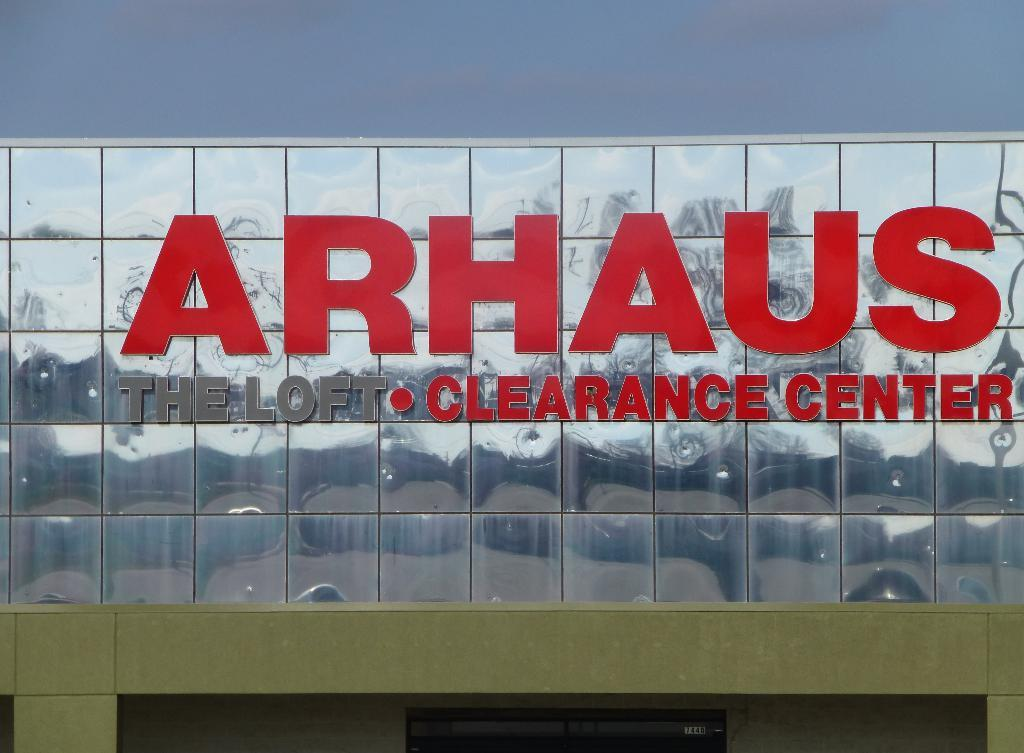<image>
Share a concise interpretation of the image provided. A sign for Arhaus Clearance Center is posted on mirrored panels. 